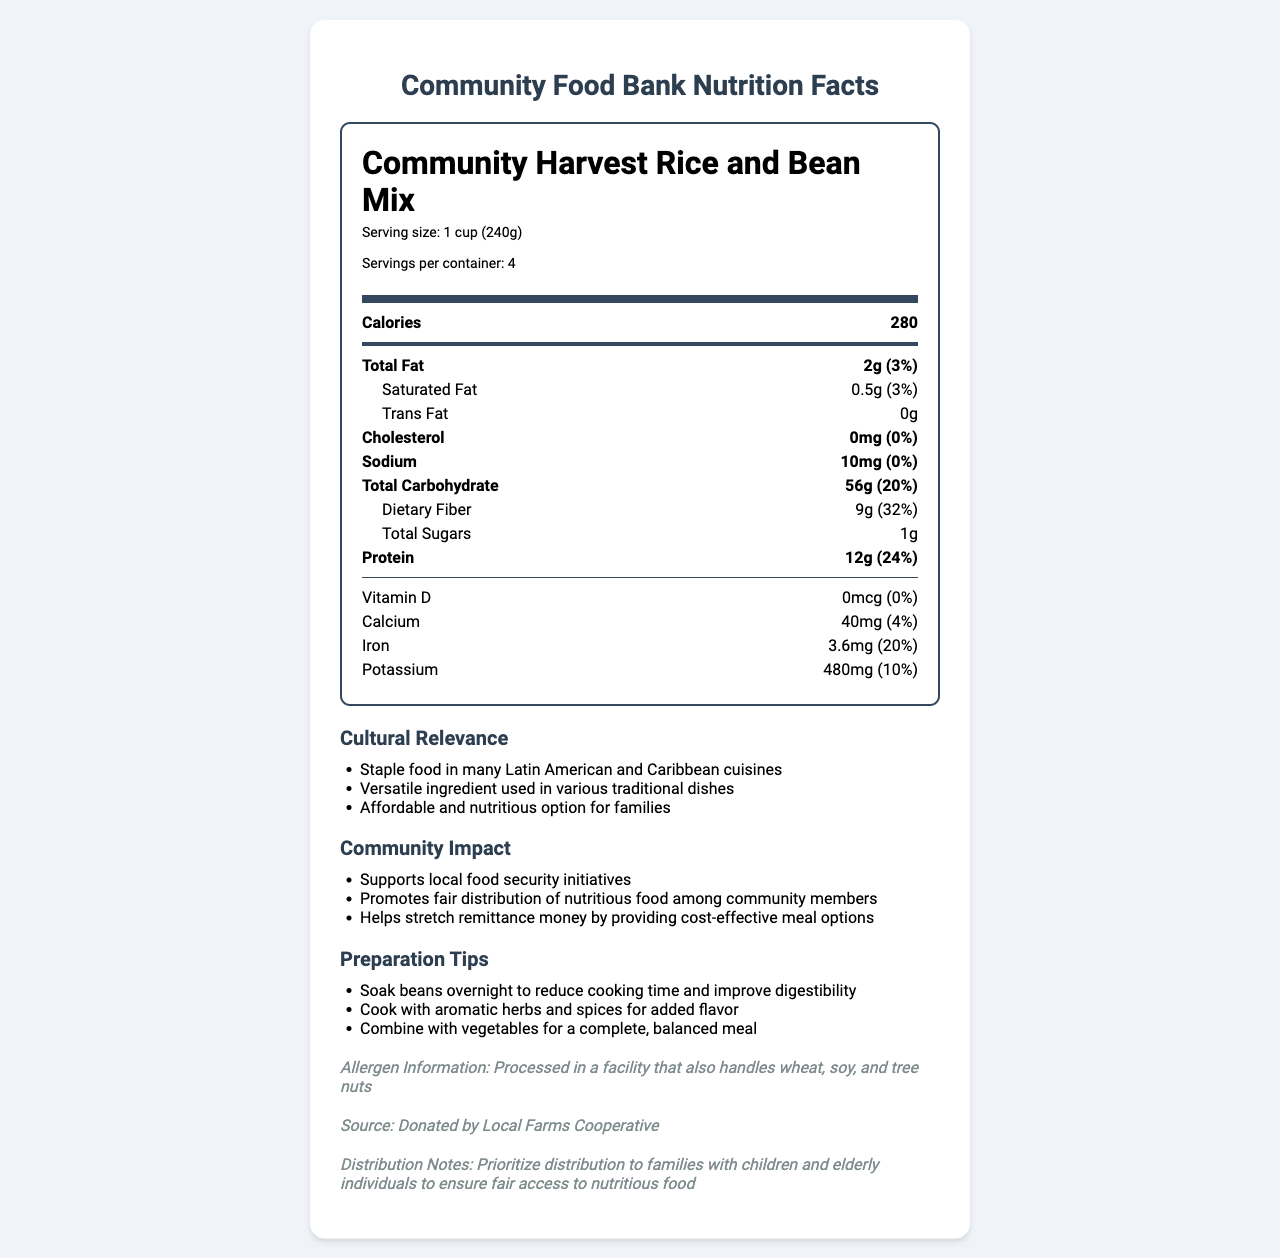what is the serving size for the Community Harvest Rice and Bean Mix? The serving size is stated at the top part of the nutrition label.
Answer: 1 cup (240g) how many calories are in one serving? The calories are listed right below the serving size information.
Answer: 280 what percentage of the daily value for dietary fiber does one serving provide? The daily value percentage for dietary fiber is shown in the nutrition information section under Total Carbohydrate.
Answer: 32% how many grams of protein are in one serving? The protein amount per serving is listed under the nutrition section.
Answer: 12g does the product contain any trans fat? The amount of trans fat is indicated as 0g in the nutrition section.
Answer: No which allergen information is mentioned about this product? The allergen information is at the bottom of the document under the allergen-info section.
Answer: Processed in a facility that also handles wheat, soy, and tree nuts is there any Vitamin D in the product? Vitamin D amount is stated as 0mcg and 0% of daily value.
Answer: No where was the product sourced from? The source information is provided at the bottom of the document under the source section.
Answer: Donated by Local Farms Cooperative which of the following is not a community impact mentioned? A. Promotes fair distribution of nutritious food B. Provides gourmet meal options C. Supports local food security initiatives The document indicates community impact points, and providing gourmet meal options is not listed.
Answer: B what is the correct daily value percentage for iron in one serving? A. 10% B. 20% C. 15% D. 5% The daily value percentage for iron is listed as 20%.
Answer: B can this product be helpful in stretching remittance money? One of the community impacts stated is that it helps stretch remittance money by providing cost-effective meal options.
Answer: Yes is the product relevant in traditional Latin American and Caribbean cuisines? Cultural relevance mentions that this is a staple food in many Latin American and Caribbean cuisines.
Answer: Yes summarize the main purpose of this document. The summary includes all key elements such as nutritional information, cultural relevance, community impact, and additional notes on allergens, source, and distribution.
Answer: The document provides a comprehensive nutrition facts label for the Community Harvest Rice and Bean Mix, including its serving size, nutritional value, cultural relevance, community impact, preparation tips, allergen information, and distribution notes. It aims to inform community food bank recipients about the benefits and proper usage of the donated food item. what is the distribution priority for this product? The distribution notes specifically mention prioritizing families with children and elderly individuals to ensure fair access to nutritious food.
Answer: Families with children and elderly individuals how long should the beans in the mix be soaked to reduce cooking time? The preparation tips mention soaking the beans overnight to reduce cooking time and improve digestibility.
Answer: Overnight can we determine the cost of this product from the document? The document does not provide any data regarding the cost of the Community Harvest Rice and Bean Mix.
Answer: Not enough information 